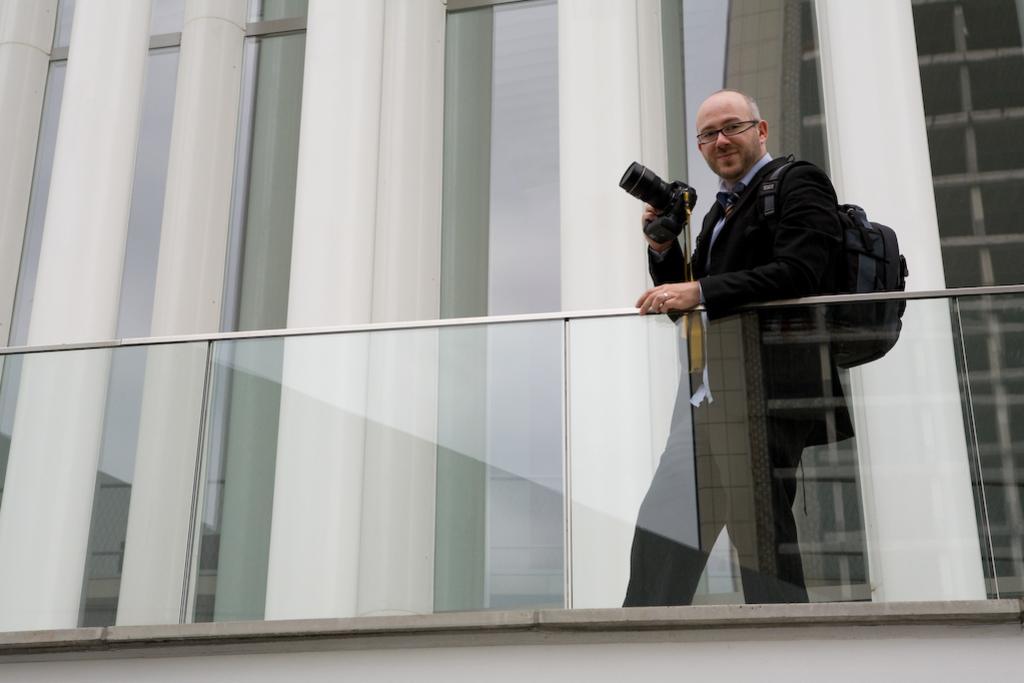How would you summarize this image in a sentence or two? In this picture I can see a person standing and holding the camera. I can see the glass wall. I can see the building in the background. 